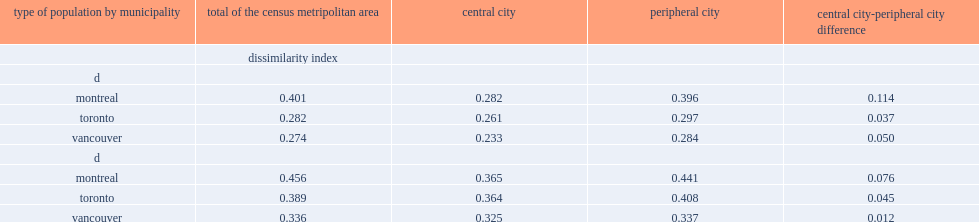Which municipality has the greatest residential concentration? Montreal. Which municipality has the greatest residential concentration? Montreal. Which municipality has higher concentration of population of immigrants, toronto or vancouver? Toronto. Which municipality has higher concentration of population with an immigrant background, toronto or vancouver? Toronto. Which type of population has higher values of d in each cma, population with an immigrant background or population of immigrants? D. Which type of municopalities has higher values of d, peropheral municipalities or central municipalities? Peripheral city. 